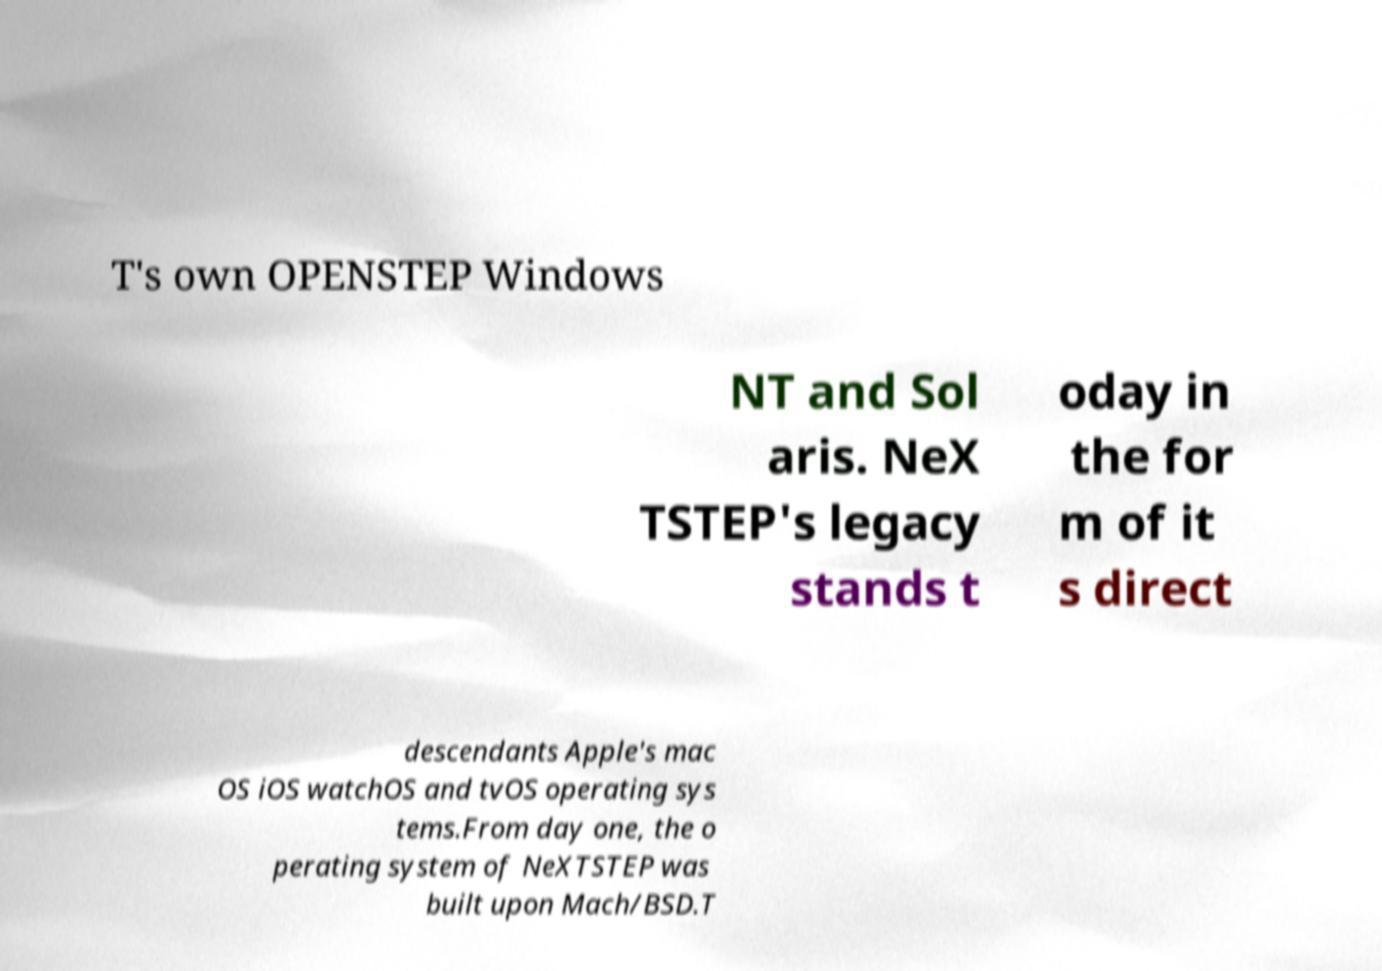Can you read and provide the text displayed in the image?This photo seems to have some interesting text. Can you extract and type it out for me? T's own OPENSTEP Windows NT and Sol aris. NeX TSTEP's legacy stands t oday in the for m of it s direct descendants Apple's mac OS iOS watchOS and tvOS operating sys tems.From day one, the o perating system of NeXTSTEP was built upon Mach/BSD.T 